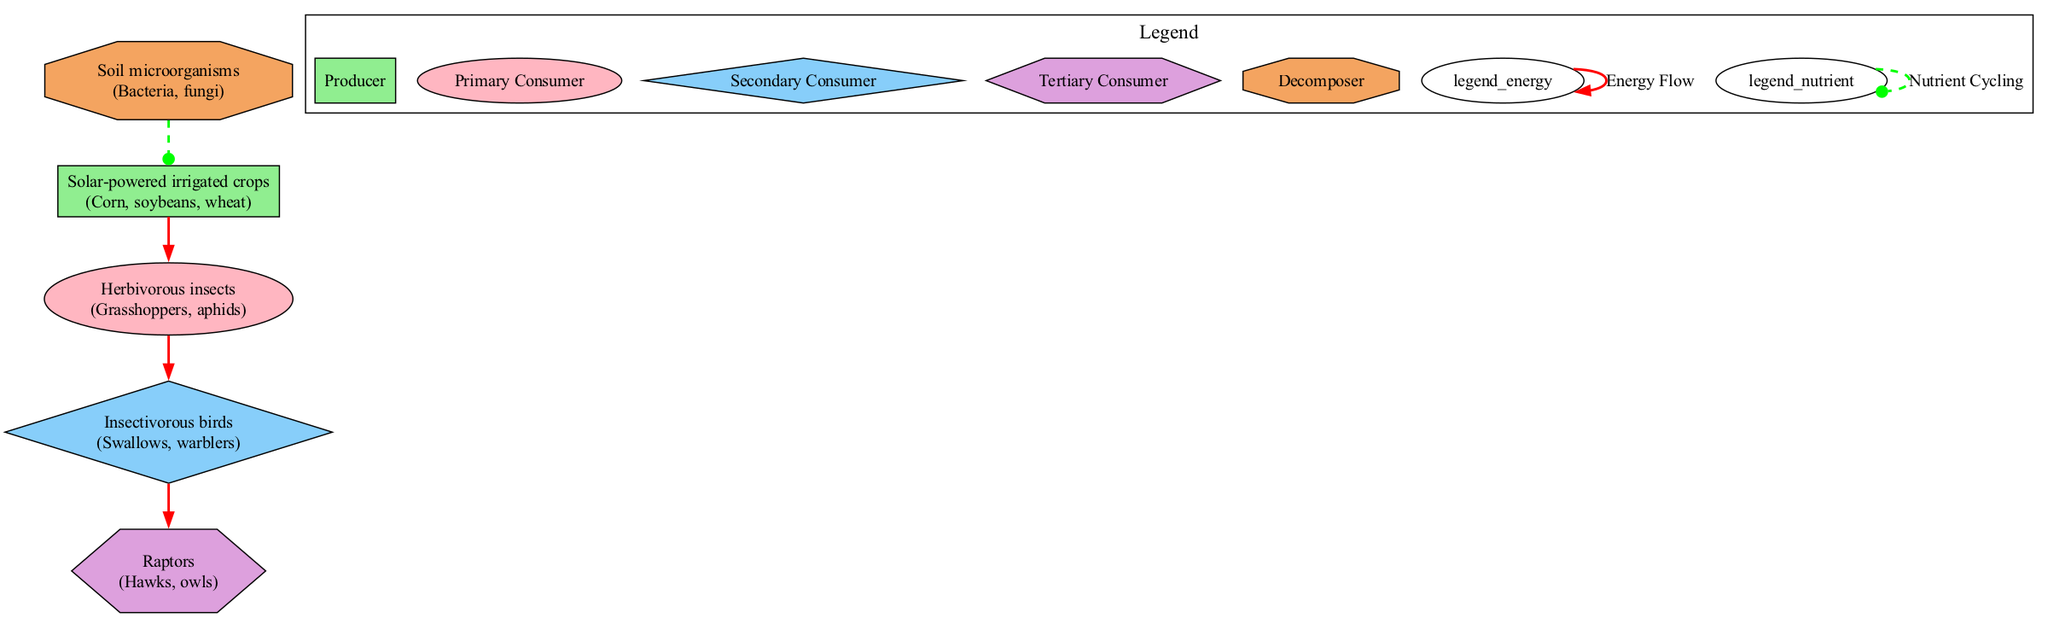What is the primary producer in this diagram? The primary producer is the first element in the food chain, which is "Solar-powered irrigated crops". This node represents the organisms that convert solar energy into chemical energy through photosynthesis, specifically crops like corn, soybeans, and wheat.
Answer: Solar-powered irrigated crops How many levels of consumers are present in the food chain? The food chain consists of three levels of consumers: primary, secondary, and tertiary. These correspond to the nodes "Herbivorous insects" as primary consumers, "Insectivorous birds" as secondary consumers, and "Raptors" as tertiary consumers. The counting of consumer levels reveals three distinct levels.
Answer: 3 What type of relationship exists between soil microorganisms and solar-powered irrigated crops? The relationship is characterized as "nutrient cycling", indicated by a dashed green line connecting the two nodes in the diagram. This type of relationship illustrates the flow of nutrients from the decomposer (soil microorganisms) back to the producer (solar-powered irrigated crops), enhancing soil fertility.
Answer: Nutrient cycling Which organism directly consumes herbivorous insects? The organism that directly consumes herbivorous insects is "Insectivorous birds". This relationship is depicted by a solid red arrow pointing from "Herbivorous insects" to "Insectivorous birds", showing the primary consumption relationship.
Answer: Insectivorous birds What color represents energy flow in the diagram? Energy flow is represented by red lines in the diagram. Each solid red line indicates the flow of energy from one level of the food chain to another, connecting producers and consumers.
Answer: Red 